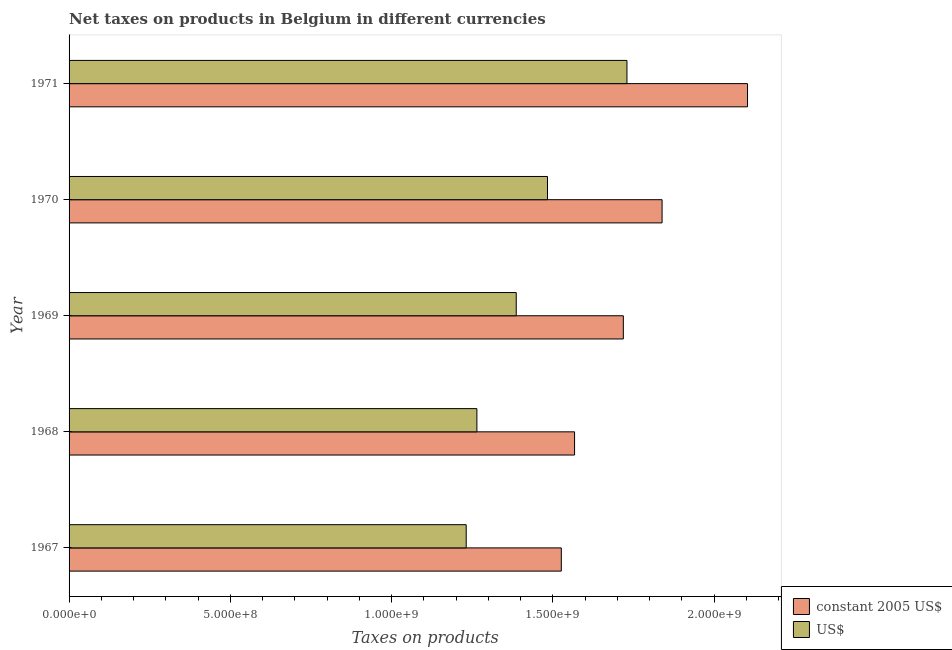Are the number of bars per tick equal to the number of legend labels?
Your answer should be compact. Yes. How many bars are there on the 1st tick from the bottom?
Your answer should be compact. 2. What is the label of the 5th group of bars from the top?
Your answer should be compact. 1967. What is the net taxes in constant 2005 us$ in 1969?
Keep it short and to the point. 1.72e+09. Across all years, what is the maximum net taxes in constant 2005 us$?
Provide a short and direct response. 2.10e+09. Across all years, what is the minimum net taxes in us$?
Provide a succinct answer. 1.23e+09. In which year was the net taxes in us$ maximum?
Your answer should be very brief. 1971. In which year was the net taxes in us$ minimum?
Your answer should be very brief. 1967. What is the total net taxes in us$ in the graph?
Your response must be concise. 7.10e+09. What is the difference between the net taxes in constant 2005 us$ in 1967 and that in 1970?
Your answer should be very brief. -3.12e+08. What is the difference between the net taxes in us$ in 1969 and the net taxes in constant 2005 us$ in 1971?
Provide a short and direct response. -7.17e+08. What is the average net taxes in constant 2005 us$ per year?
Ensure brevity in your answer.  1.75e+09. In the year 1967, what is the difference between the net taxes in us$ and net taxes in constant 2005 us$?
Your answer should be very brief. -2.95e+08. What is the ratio of the net taxes in us$ in 1967 to that in 1970?
Your response must be concise. 0.83. Is the difference between the net taxes in constant 2005 us$ in 1967 and 1971 greater than the difference between the net taxes in us$ in 1967 and 1971?
Offer a terse response. No. What is the difference between the highest and the second highest net taxes in constant 2005 us$?
Offer a terse response. 2.65e+08. What is the difference between the highest and the lowest net taxes in constant 2005 us$?
Provide a succinct answer. 5.77e+08. In how many years, is the net taxes in constant 2005 us$ greater than the average net taxes in constant 2005 us$ taken over all years?
Offer a terse response. 2. What does the 1st bar from the top in 1968 represents?
Ensure brevity in your answer.  US$. What does the 2nd bar from the bottom in 1968 represents?
Your response must be concise. US$. How many bars are there?
Your answer should be very brief. 10. Does the graph contain grids?
Provide a succinct answer. No. Where does the legend appear in the graph?
Ensure brevity in your answer.  Bottom right. What is the title of the graph?
Your response must be concise. Net taxes on products in Belgium in different currencies. What is the label or title of the X-axis?
Your answer should be compact. Taxes on products. What is the Taxes on products of constant 2005 US$ in 1967?
Your answer should be very brief. 1.53e+09. What is the Taxes on products of US$ in 1967?
Provide a short and direct response. 1.23e+09. What is the Taxes on products in constant 2005 US$ in 1968?
Offer a terse response. 1.57e+09. What is the Taxes on products in US$ in 1968?
Give a very brief answer. 1.26e+09. What is the Taxes on products of constant 2005 US$ in 1969?
Keep it short and to the point. 1.72e+09. What is the Taxes on products in US$ in 1969?
Offer a very short reply. 1.39e+09. What is the Taxes on products of constant 2005 US$ in 1970?
Your response must be concise. 1.84e+09. What is the Taxes on products of US$ in 1970?
Give a very brief answer. 1.48e+09. What is the Taxes on products in constant 2005 US$ in 1971?
Provide a short and direct response. 2.10e+09. What is the Taxes on products in US$ in 1971?
Your response must be concise. 1.73e+09. Across all years, what is the maximum Taxes on products in constant 2005 US$?
Make the answer very short. 2.10e+09. Across all years, what is the maximum Taxes on products of US$?
Offer a terse response. 1.73e+09. Across all years, what is the minimum Taxes on products in constant 2005 US$?
Keep it short and to the point. 1.53e+09. Across all years, what is the minimum Taxes on products of US$?
Offer a terse response. 1.23e+09. What is the total Taxes on products in constant 2005 US$ in the graph?
Your answer should be very brief. 8.75e+09. What is the total Taxes on products of US$ in the graph?
Your response must be concise. 7.10e+09. What is the difference between the Taxes on products in constant 2005 US$ in 1967 and that in 1968?
Keep it short and to the point. -4.11e+07. What is the difference between the Taxes on products of US$ in 1967 and that in 1968?
Give a very brief answer. -3.31e+07. What is the difference between the Taxes on products in constant 2005 US$ in 1967 and that in 1969?
Your answer should be very brief. -1.92e+08. What is the difference between the Taxes on products of US$ in 1967 and that in 1969?
Keep it short and to the point. -1.55e+08. What is the difference between the Taxes on products of constant 2005 US$ in 1967 and that in 1970?
Make the answer very short. -3.12e+08. What is the difference between the Taxes on products of US$ in 1967 and that in 1970?
Provide a succinct answer. -2.52e+08. What is the difference between the Taxes on products of constant 2005 US$ in 1967 and that in 1971?
Provide a short and direct response. -5.77e+08. What is the difference between the Taxes on products in US$ in 1967 and that in 1971?
Give a very brief answer. -4.98e+08. What is the difference between the Taxes on products in constant 2005 US$ in 1968 and that in 1969?
Provide a succinct answer. -1.51e+08. What is the difference between the Taxes on products of US$ in 1968 and that in 1969?
Give a very brief answer. -1.22e+08. What is the difference between the Taxes on products of constant 2005 US$ in 1968 and that in 1970?
Provide a succinct answer. -2.71e+08. What is the difference between the Taxes on products of US$ in 1968 and that in 1970?
Offer a terse response. -2.19e+08. What is the difference between the Taxes on products in constant 2005 US$ in 1968 and that in 1971?
Give a very brief answer. -5.36e+08. What is the difference between the Taxes on products in US$ in 1968 and that in 1971?
Your response must be concise. -4.65e+08. What is the difference between the Taxes on products in constant 2005 US$ in 1969 and that in 1970?
Provide a short and direct response. -1.20e+08. What is the difference between the Taxes on products in US$ in 1969 and that in 1970?
Provide a short and direct response. -9.69e+07. What is the difference between the Taxes on products in constant 2005 US$ in 1969 and that in 1971?
Your response must be concise. -3.85e+08. What is the difference between the Taxes on products in US$ in 1969 and that in 1971?
Offer a very short reply. -3.43e+08. What is the difference between the Taxes on products in constant 2005 US$ in 1970 and that in 1971?
Provide a short and direct response. -2.65e+08. What is the difference between the Taxes on products of US$ in 1970 and that in 1971?
Make the answer very short. -2.46e+08. What is the difference between the Taxes on products of constant 2005 US$ in 1967 and the Taxes on products of US$ in 1968?
Ensure brevity in your answer.  2.62e+08. What is the difference between the Taxes on products of constant 2005 US$ in 1967 and the Taxes on products of US$ in 1969?
Ensure brevity in your answer.  1.40e+08. What is the difference between the Taxes on products in constant 2005 US$ in 1967 and the Taxes on products in US$ in 1970?
Provide a short and direct response. 4.28e+07. What is the difference between the Taxes on products of constant 2005 US$ in 1967 and the Taxes on products of US$ in 1971?
Provide a succinct answer. -2.04e+08. What is the difference between the Taxes on products in constant 2005 US$ in 1968 and the Taxes on products in US$ in 1969?
Offer a terse response. 1.81e+08. What is the difference between the Taxes on products in constant 2005 US$ in 1968 and the Taxes on products in US$ in 1970?
Offer a very short reply. 8.39e+07. What is the difference between the Taxes on products in constant 2005 US$ in 1968 and the Taxes on products in US$ in 1971?
Provide a short and direct response. -1.62e+08. What is the difference between the Taxes on products in constant 2005 US$ in 1969 and the Taxes on products in US$ in 1970?
Your answer should be compact. 2.35e+08. What is the difference between the Taxes on products of constant 2005 US$ in 1969 and the Taxes on products of US$ in 1971?
Your response must be concise. -1.13e+07. What is the difference between the Taxes on products in constant 2005 US$ in 1970 and the Taxes on products in US$ in 1971?
Your answer should be compact. 1.09e+08. What is the average Taxes on products of constant 2005 US$ per year?
Your answer should be compact. 1.75e+09. What is the average Taxes on products in US$ per year?
Keep it short and to the point. 1.42e+09. In the year 1967, what is the difference between the Taxes on products in constant 2005 US$ and Taxes on products in US$?
Offer a terse response. 2.95e+08. In the year 1968, what is the difference between the Taxes on products of constant 2005 US$ and Taxes on products of US$?
Your response must be concise. 3.03e+08. In the year 1969, what is the difference between the Taxes on products in constant 2005 US$ and Taxes on products in US$?
Your answer should be compact. 3.32e+08. In the year 1970, what is the difference between the Taxes on products of constant 2005 US$ and Taxes on products of US$?
Provide a succinct answer. 3.55e+08. In the year 1971, what is the difference between the Taxes on products in constant 2005 US$ and Taxes on products in US$?
Keep it short and to the point. 3.74e+08. What is the ratio of the Taxes on products in constant 2005 US$ in 1967 to that in 1968?
Give a very brief answer. 0.97. What is the ratio of the Taxes on products of US$ in 1967 to that in 1968?
Provide a short and direct response. 0.97. What is the ratio of the Taxes on products of constant 2005 US$ in 1967 to that in 1969?
Your answer should be very brief. 0.89. What is the ratio of the Taxes on products of US$ in 1967 to that in 1969?
Offer a very short reply. 0.89. What is the ratio of the Taxes on products of constant 2005 US$ in 1967 to that in 1970?
Keep it short and to the point. 0.83. What is the ratio of the Taxes on products in US$ in 1967 to that in 1970?
Offer a very short reply. 0.83. What is the ratio of the Taxes on products of constant 2005 US$ in 1967 to that in 1971?
Offer a terse response. 0.73. What is the ratio of the Taxes on products in US$ in 1967 to that in 1971?
Make the answer very short. 0.71. What is the ratio of the Taxes on products of constant 2005 US$ in 1968 to that in 1969?
Your response must be concise. 0.91. What is the ratio of the Taxes on products of US$ in 1968 to that in 1969?
Provide a succinct answer. 0.91. What is the ratio of the Taxes on products in constant 2005 US$ in 1968 to that in 1970?
Make the answer very short. 0.85. What is the ratio of the Taxes on products of US$ in 1968 to that in 1970?
Keep it short and to the point. 0.85. What is the ratio of the Taxes on products in constant 2005 US$ in 1968 to that in 1971?
Your response must be concise. 0.75. What is the ratio of the Taxes on products in US$ in 1968 to that in 1971?
Provide a short and direct response. 0.73. What is the ratio of the Taxes on products of constant 2005 US$ in 1969 to that in 1970?
Your answer should be very brief. 0.93. What is the ratio of the Taxes on products in US$ in 1969 to that in 1970?
Your answer should be compact. 0.93. What is the ratio of the Taxes on products in constant 2005 US$ in 1969 to that in 1971?
Provide a short and direct response. 0.82. What is the ratio of the Taxes on products in US$ in 1969 to that in 1971?
Keep it short and to the point. 0.8. What is the ratio of the Taxes on products in constant 2005 US$ in 1970 to that in 1971?
Offer a terse response. 0.87. What is the ratio of the Taxes on products of US$ in 1970 to that in 1971?
Offer a terse response. 0.86. What is the difference between the highest and the second highest Taxes on products in constant 2005 US$?
Give a very brief answer. 2.65e+08. What is the difference between the highest and the second highest Taxes on products of US$?
Your answer should be compact. 2.46e+08. What is the difference between the highest and the lowest Taxes on products of constant 2005 US$?
Keep it short and to the point. 5.77e+08. What is the difference between the highest and the lowest Taxes on products in US$?
Offer a terse response. 4.98e+08. 